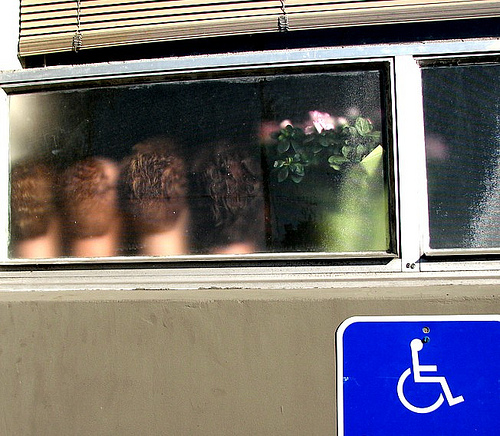<image>
Is there a plant behind the window? Yes. From this viewpoint, the plant is positioned behind the window, with the window partially or fully occluding the plant. Is there a flower above the head? Yes. The flower is positioned above the head in the vertical space, higher up in the scene. 